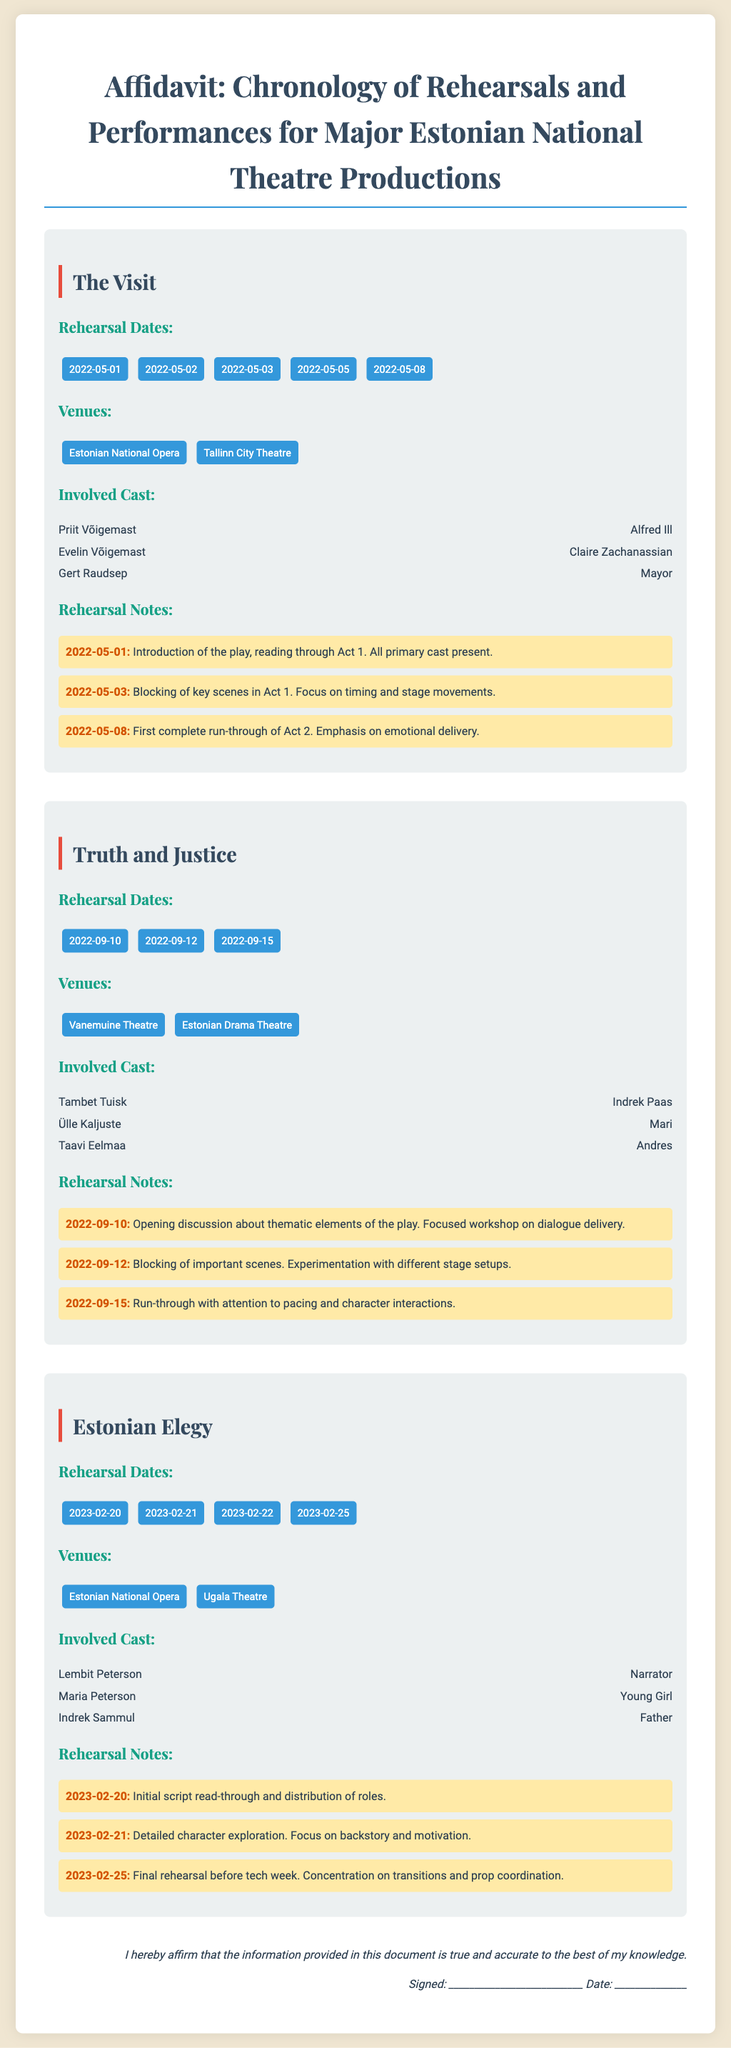What is the title of the first production? The title is provided in the document under each production section, the first one listed is "The Visit".
Answer: The Visit How many rehearsal dates are listed for "Truth and Justice"? The total number of rehearsal dates can be counted from the provided dates under "Truth and Justice", which are three dates.
Answer: 3 Who played the role of Alfred Ill? The cast details provide specific names associated with their roles; Alfred Ill is played by Priit Võigemast.
Answer: Priit Võigemast What venue hosted rehearsals for "Estonian Elegy"? The venue names are listed under "Venues"; one of them is Estonian National Opera.
Answer: Estonian National Opera On what date was the first complete run-through of Act 2 for "The Visit"? This information is found in the rehearsal notes, indicating the specific date for the run-through as May 8, 2022.
Answer: 2022-05-08 How many cast members are listed for the production "Truth and Justice"? By counting the cast members under "Involved Cast", three members are identified for this production.
Answer: 3 What was the focus of the rehearsal on September 12, 2022, for "Truth and Justice"? The rehearsal notes state that the focus was on blocking important scenes and experimenting with different stage setups.
Answer: Blocking important scenes What is the last rehearsal date for "Estonian Elegy"? The last date is provided in the rehearsal dates section for "Estonian Elegy", which is February 25, 2023.
Answer: 2023-02-25 Is there a discussion about thematic elements for "The Visit"? The content in the document under rehearsal notes indicates an introduction and reading session on the first day, but not specifically a thematic discussion.
Answer: No 